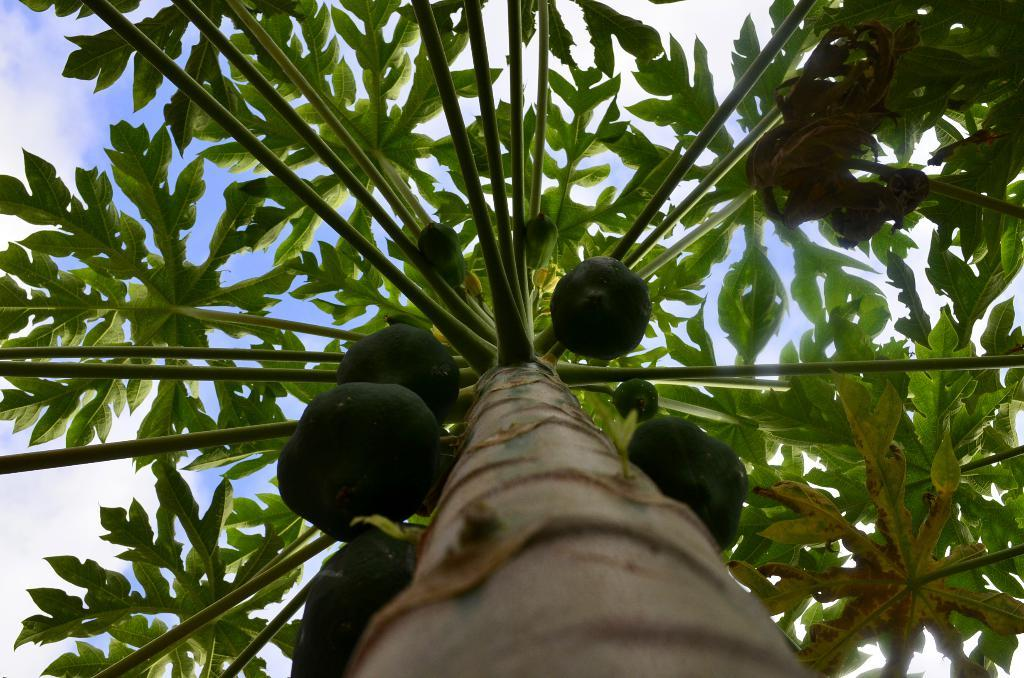What type of tree is present in the image? There is a papaya tree in the image. What can be seen on the tree? There are raw papayas on the tree. How would you describe the sky in the image? The sky is cloudy in the image. Can you tell me how many buttons are on the goose in the image? There is no goose or button present in the image; it features a papaya tree with raw papayas. What country is depicted in the image? The image does not depict a specific country; it shows a papaya tree with raw papayas and a cloudy sky. 